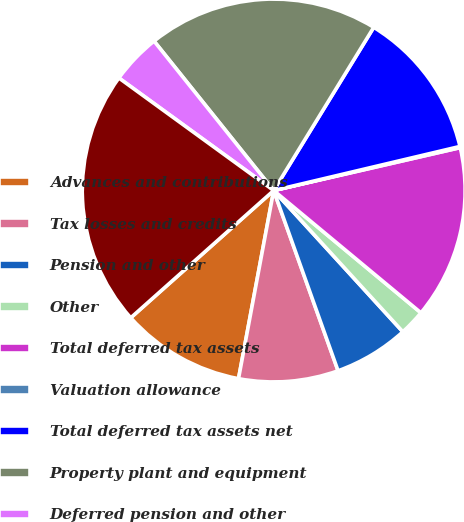Convert chart to OTSL. <chart><loc_0><loc_0><loc_500><loc_500><pie_chart><fcel>Advances and contributions<fcel>Tax losses and credits<fcel>Pension and other<fcel>Other<fcel>Total deferred tax assets<fcel>Valuation allowance<fcel>Total deferred tax assets net<fcel>Property plant and equipment<fcel>Deferred pension and other<fcel>Total deferred tax liabilities<nl><fcel>10.48%<fcel>8.4%<fcel>6.33%<fcel>2.18%<fcel>14.63%<fcel>0.1%<fcel>12.55%<fcel>19.5%<fcel>4.25%<fcel>21.58%<nl></chart> 